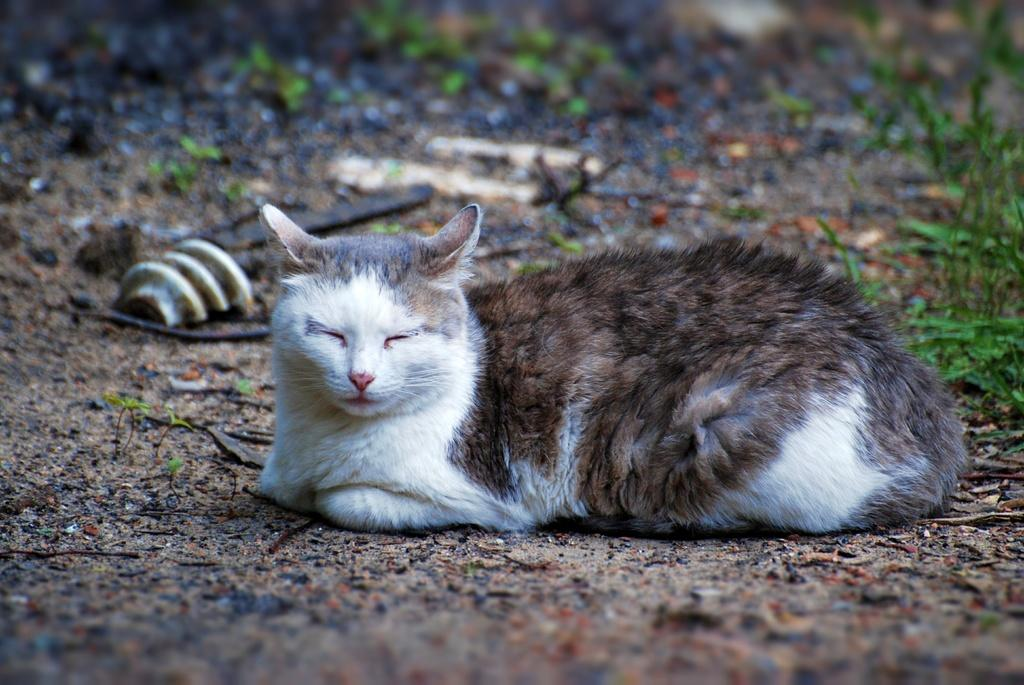Where was the image taken? The image is taken outdoors. What type of surface is visible in the image? There is a ground with grass in the image. What else can be seen on the ground? Dry leaves are present on the ground. What animal is in the middle of the image? There is a cat in the middle of the image. Where is the cat located? The cat is on the ground. What type of notebook is the cat holding in the image? There is no notebook present in the image; the cat is simply on the ground. 